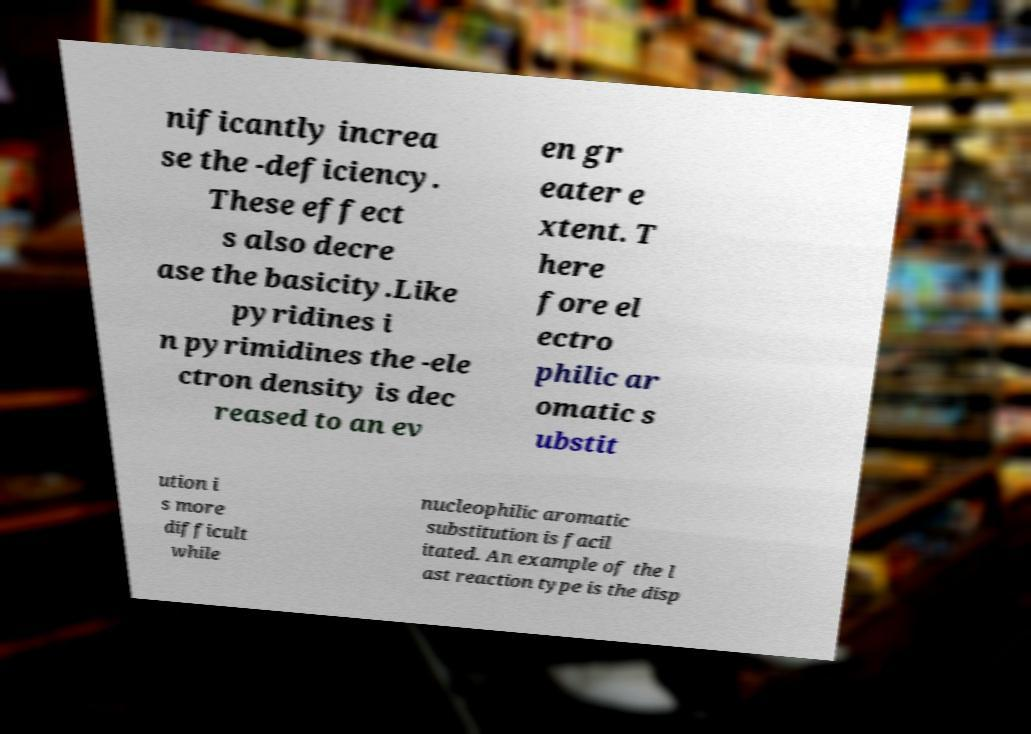What messages or text are displayed in this image? I need them in a readable, typed format. nificantly increa se the -deficiency. These effect s also decre ase the basicity.Like pyridines i n pyrimidines the -ele ctron density is dec reased to an ev en gr eater e xtent. T here fore el ectro philic ar omatic s ubstit ution i s more difficult while nucleophilic aromatic substitution is facil itated. An example of the l ast reaction type is the disp 